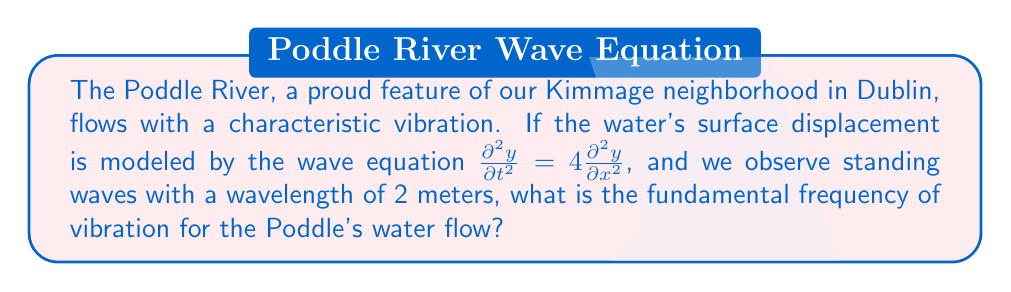Give your solution to this math problem. Let's approach this step-by-step:

1) The general form of the wave equation is:

   $$\frac{\partial^2 y}{\partial t^2} = v^2 \frac{\partial^2 y}{\partial x^2}$$

   where $v$ is the wave speed.

2) Comparing this to our given equation, we see that $v^2 = 4$, so $v = 2$ m/s.

3) For a standing wave, the relationship between wavelength ($\lambda$), frequency ($f$), and wave speed ($v$) is:

   $$v = \lambda f$$

4) We're given that the wavelength $\lambda = 2$ meters. Let's substitute our known values:

   $$2 = 2f$$

5) Solving for $f$:

   $$f = 1 \text{ Hz}$$

6) This is the fundamental frequency of vibration for the Poddle's water flow.
Answer: 1 Hz 